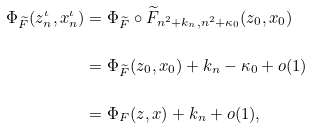Convert formula to latex. <formula><loc_0><loc_0><loc_500><loc_500>\Phi _ { \widetilde { F } } ( z ^ { \iota } _ { n } , x ^ { \iota } _ { n } ) & = \Phi _ { \widetilde { F } } \circ \widetilde { F } _ { n ^ { 2 } + k _ { n } , n ^ { 2 } + \kappa _ { 0 } } ( z _ { 0 } , x _ { 0 } ) \\ & = \Phi _ { \widetilde { F } } ( z _ { 0 } , x _ { 0 } ) + k _ { n } - \kappa _ { 0 } + o ( 1 ) \\ & = \Phi _ { F } ( z , x ) + k _ { n } + o ( 1 ) ,</formula> 